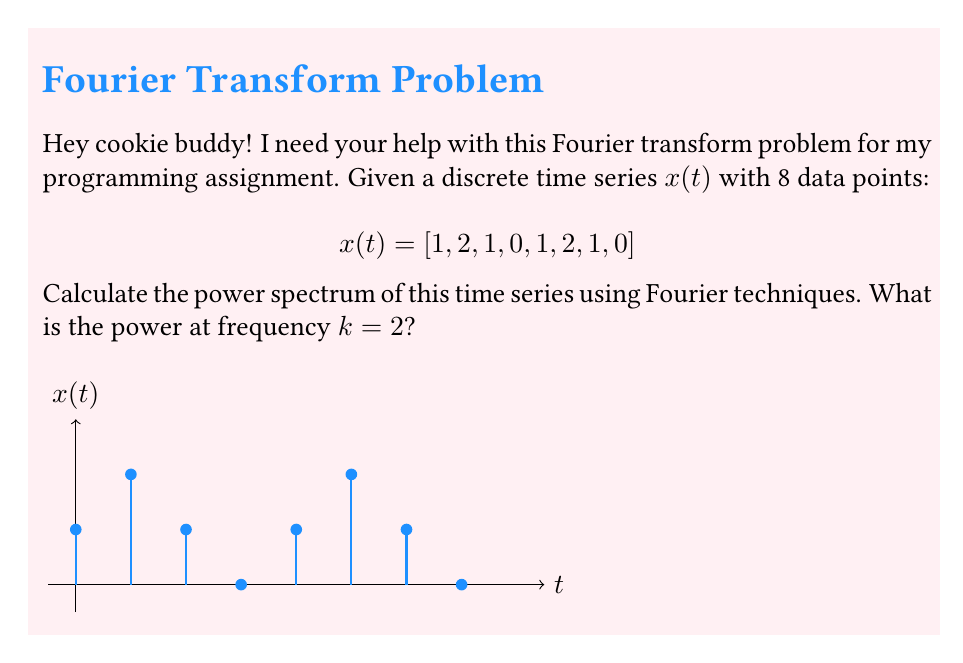Show me your answer to this math problem. Let's approach this step-by-step:

1) First, we need to calculate the Discrete Fourier Transform (DFT) of the time series. The DFT is given by:

   $$X(k) = \sum_{n=0}^{N-1} x(n) e^{-i2\pi kn/N}$$

   where N is the number of data points (8 in this case).

2) For k=2, we calculate:

   $$X(2) = \sum_{n=0}^{7} x(n) e^{-i2\pi 2n/8}$$

3) Expanding this:

   $$X(2) = 1 + 2e^{-i\pi/2} + 1e^{-i\pi} + 0e^{-i3\pi/2} + 1e^{-i2\pi} + 2e^{-i5\pi/2} + 1e^{-i3\pi} + 0e^{-i7\pi/2}$$

4) Simplifying (noting that $e^{-i2\pi} = 1$, $e^{-i\pi} = -1$, $e^{-i\pi/2} = -i$, $e^{-i3\pi/2} = i$):

   $$X(2) = 1 - 2i - 1 + 1 + 2i - 1 = 0$$

5) The power spectrum is calculated as the squared magnitude of the Fourier transform:

   $$P(k) = |X(k)|^2$$

6) Therefore, the power at frequency k=2 is:

   $$P(2) = |X(2)|^2 = |0|^2 = 0$$
Answer: $0$ 